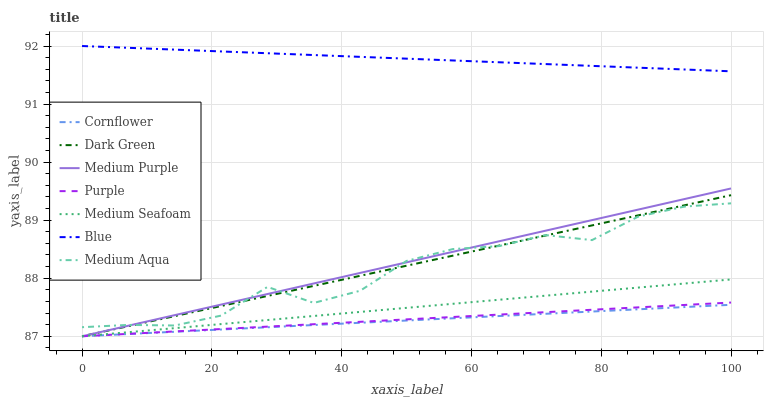Does Cornflower have the minimum area under the curve?
Answer yes or no. Yes. Does Blue have the maximum area under the curve?
Answer yes or no. Yes. Does Purple have the minimum area under the curve?
Answer yes or no. No. Does Purple have the maximum area under the curve?
Answer yes or no. No. Is Blue the smoothest?
Answer yes or no. Yes. Is Medium Aqua the roughest?
Answer yes or no. Yes. Is Cornflower the smoothest?
Answer yes or no. No. Is Cornflower the roughest?
Answer yes or no. No. Does Cornflower have the lowest value?
Answer yes or no. Yes. Does Medium Aqua have the lowest value?
Answer yes or no. No. Does Blue have the highest value?
Answer yes or no. Yes. Does Purple have the highest value?
Answer yes or no. No. Is Cornflower less than Medium Aqua?
Answer yes or no. Yes. Is Medium Aqua greater than Purple?
Answer yes or no. Yes. Does Dark Green intersect Purple?
Answer yes or no. Yes. Is Dark Green less than Purple?
Answer yes or no. No. Is Dark Green greater than Purple?
Answer yes or no. No. Does Cornflower intersect Medium Aqua?
Answer yes or no. No. 